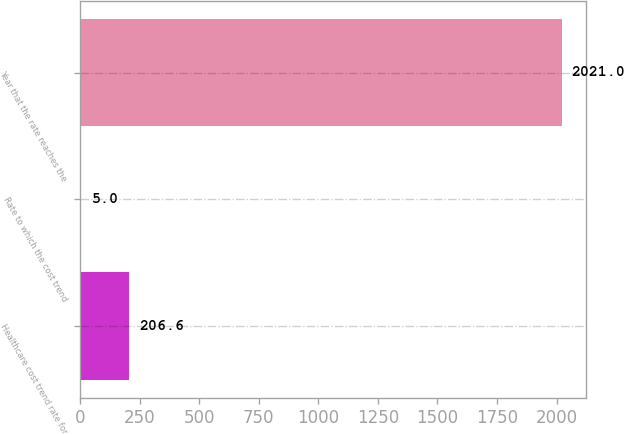Convert chart to OTSL. <chart><loc_0><loc_0><loc_500><loc_500><bar_chart><fcel>Healthcare cost trend rate for<fcel>Rate to which the cost trend<fcel>Year that the rate reaches the<nl><fcel>206.6<fcel>5<fcel>2021<nl></chart> 